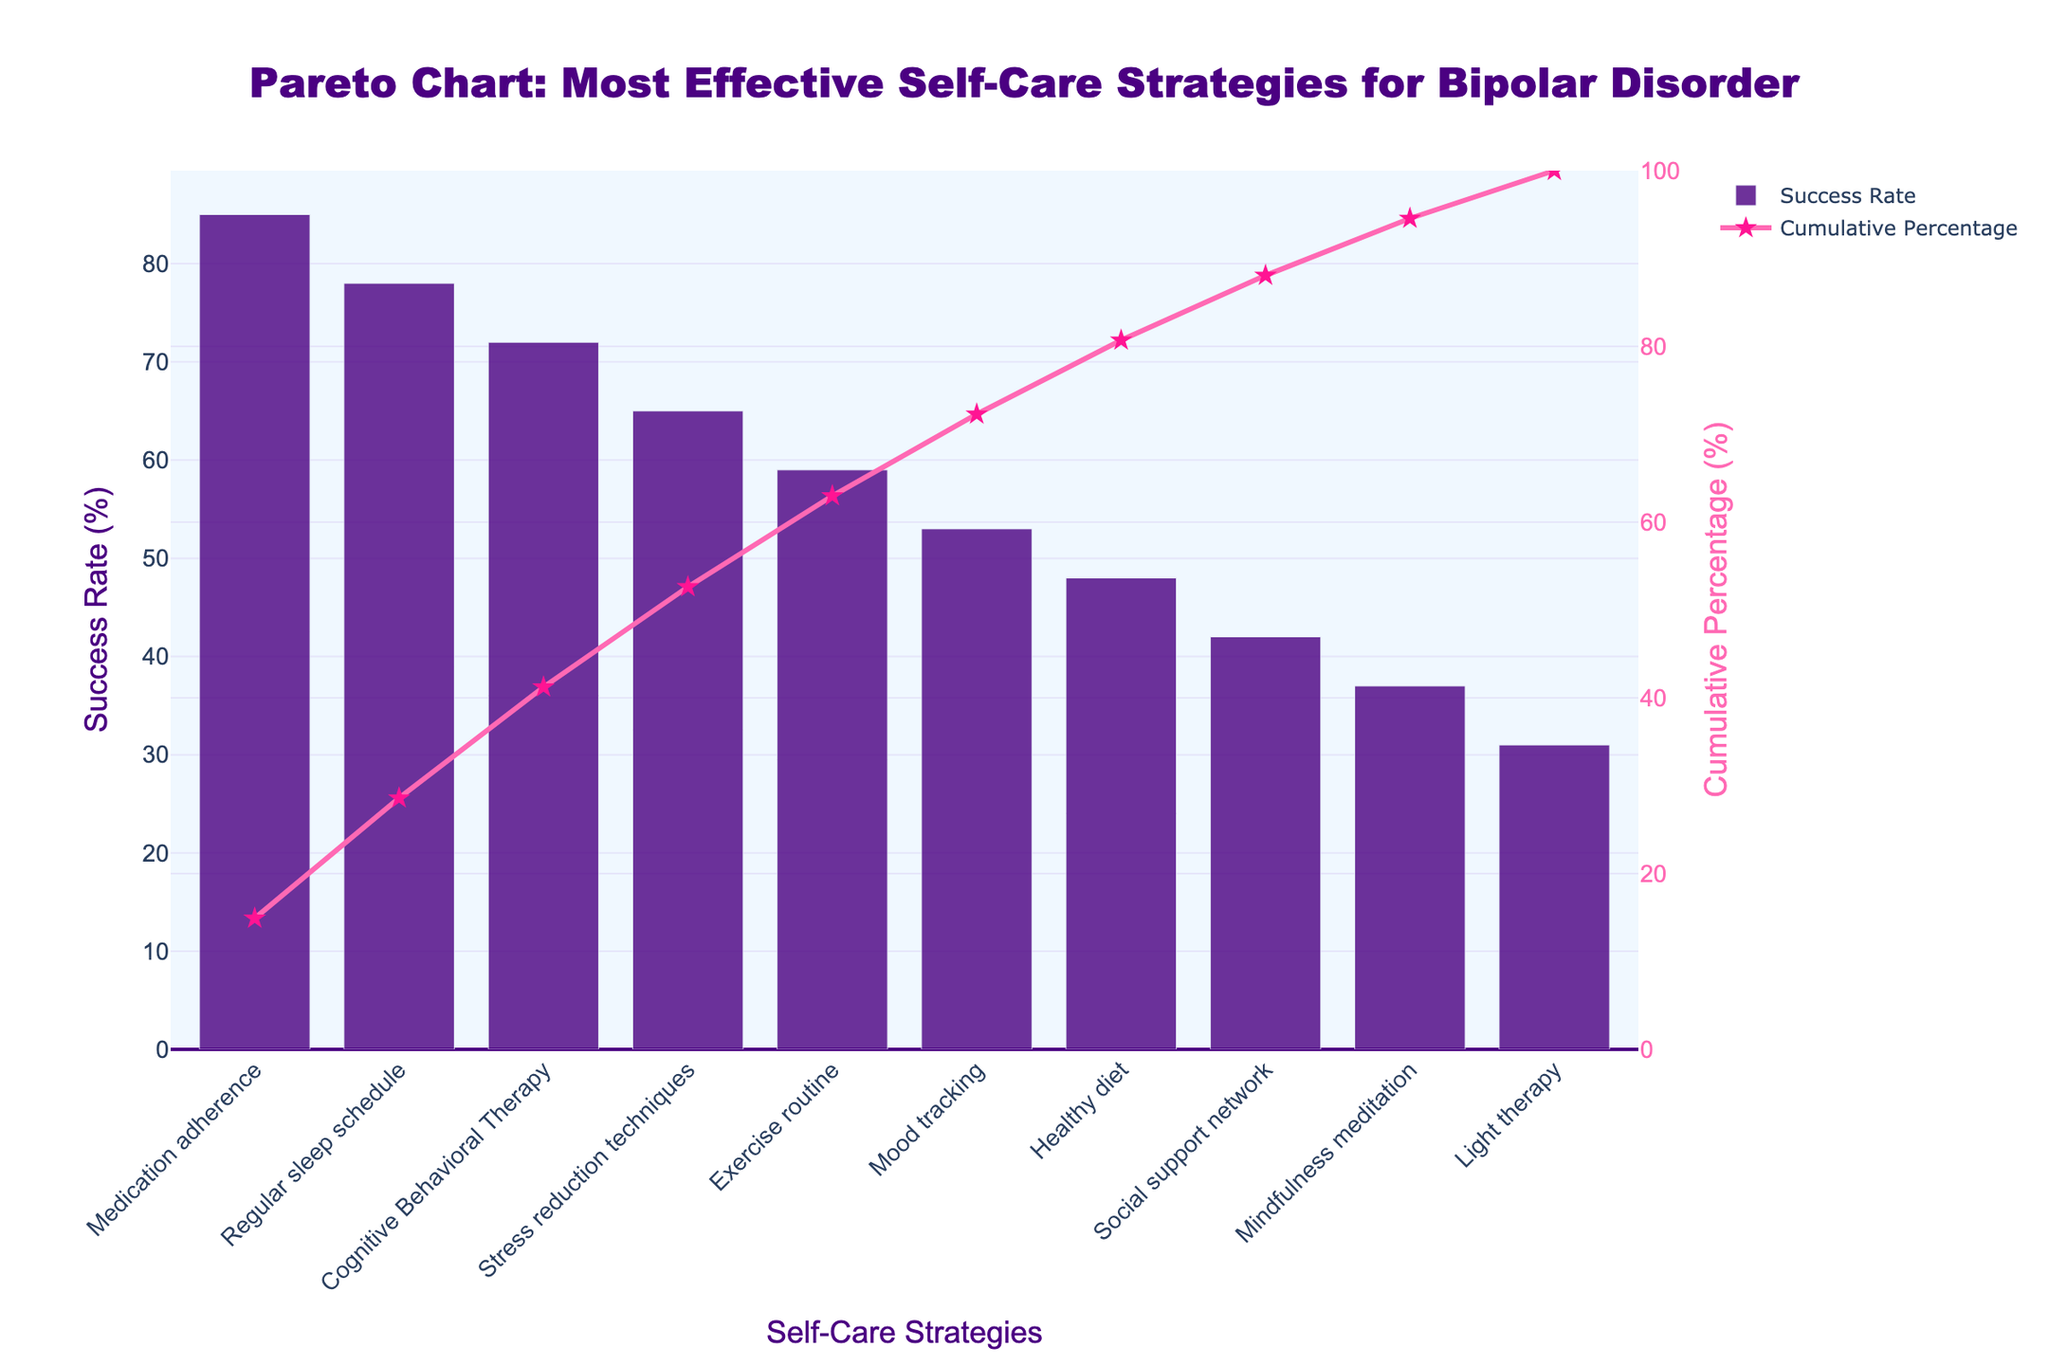What is the title of the figure? The title is usually prominently displayed at the top of the chart. In this case, it reads "Pareto Chart: Most Effective Self-Care Strategies for Bipolar Disorder".
Answer: Pareto Chart: Most Effective Self-Care Strategies for Bipolar Disorder Which self-care strategy has the highest reported success rate? Look for the tallest bar on the left side of the chart. The bar representing "Medication adherence" is the tallest, indicating the highest success rate.
Answer: Medication adherence What is the success rate of Cognitive Behavioral Therapy? Identify the bar labeled "Cognitive Behavioral Therapy" and note its height relative to the y-axis. The success rate shown is 72%.
Answer: 72% What percentage of total success is captured by combining the top three strategies? Combine the success rates of "Medication adherence," "Regular sleep schedule," and "Cognitive Behavioral Therapy". Their success rates are 85%, 78%, and 72%, respectively. Summing them up gives 85 + 78 + 72 = 235%, and divide by the total which is the sum of individual success rates to convert to a percentage.
Answer: 74.4% Between "Exercise routine" and "Healthy diet," which strategy has a higher success rate? Compare the heights of the bars for "Exercise routine" and "Healthy diet". The bar for "Exercise routine" is taller, indicating a higher success rate.
Answer: Exercise routine What is the cumulative percentage after including "Exercise routine"? Find the cumulative percentage value plotted as a line from left to right until reaching the "Exercise routine" label. From visual inspection, the line hovers around 85%.
Answer: Approximately 85% How many self-care strategies have a success rate below 50%? Identify and count the bars with heights lower than the 50% mark on the y-axis. These strategies are "Healthy diet," "Social support network," "Mindfulness meditation," and "Light therapy". There are four in total.
Answer: 4 Which self-care strategy contributes to crossing the 50% cumulative threshold? Follow the cumulative percentage line until it crosses 50%. The corresponding strategy at this point is "Cognitive Behavioral Therapy".
Answer: Cognitive Behavioral Therapy What is the difference in success rates between "Medication adherence" and "Light therapy"? Subtract the success rate of "Light therapy" (31%) from "Medication adherence" (85%). The difference is 85 - 31 = 54%.
Answer: 54% Which strategy appears to be the least effective based on this chart? Look for the shortest bar on the chart. The bar representing "Light therapy" is the shortest, indicating the lowest success rate at 31%.
Answer: Light therapy 